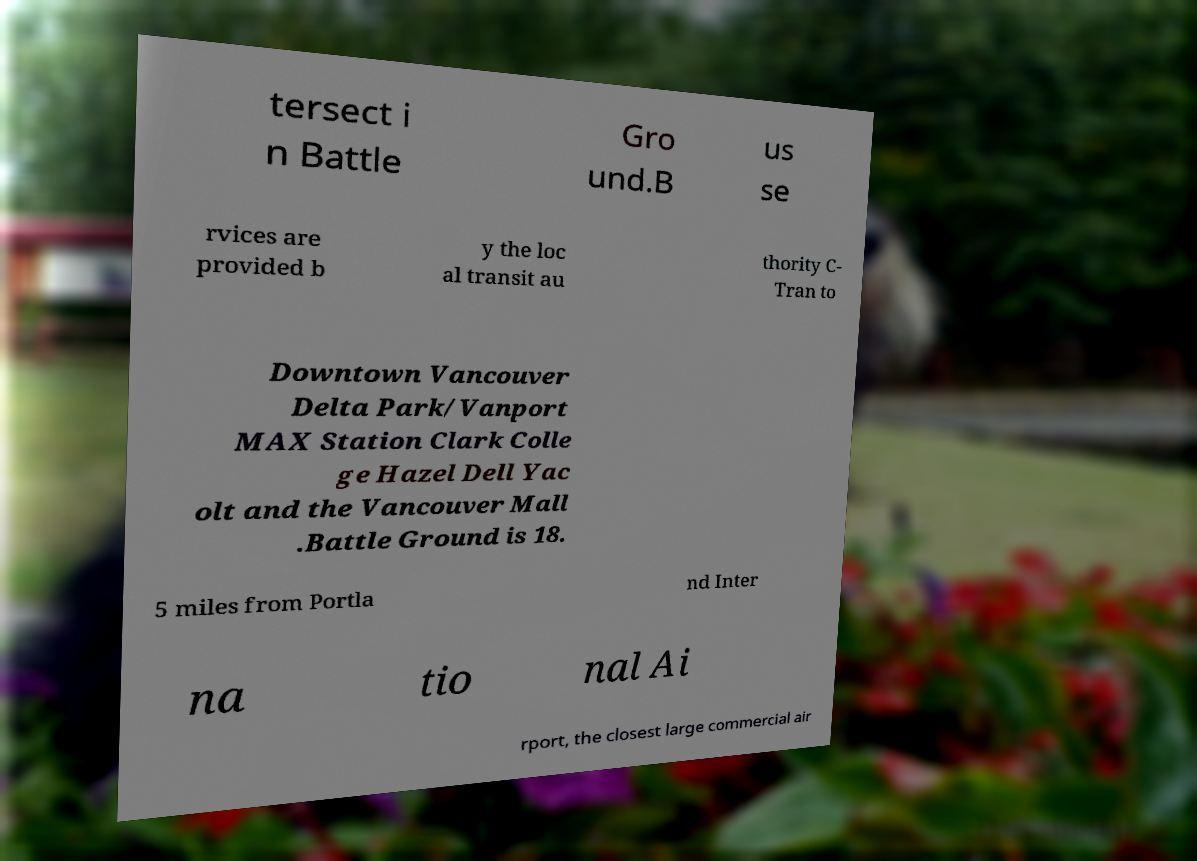There's text embedded in this image that I need extracted. Can you transcribe it verbatim? tersect i n Battle Gro und.B us se rvices are provided b y the loc al transit au thority C- Tran to Downtown Vancouver Delta Park/Vanport MAX Station Clark Colle ge Hazel Dell Yac olt and the Vancouver Mall .Battle Ground is 18. 5 miles from Portla nd Inter na tio nal Ai rport, the closest large commercial air 